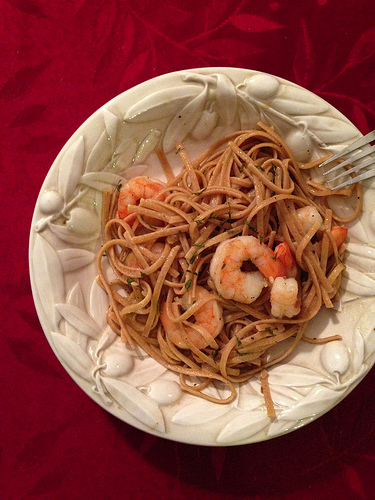<image>
Is the pasta in the plate? Yes. The pasta is contained within or inside the plate, showing a containment relationship. Where is the fork in relation to the plate? Is it next to the plate? Yes. The fork is positioned adjacent to the plate, located nearby in the same general area. 